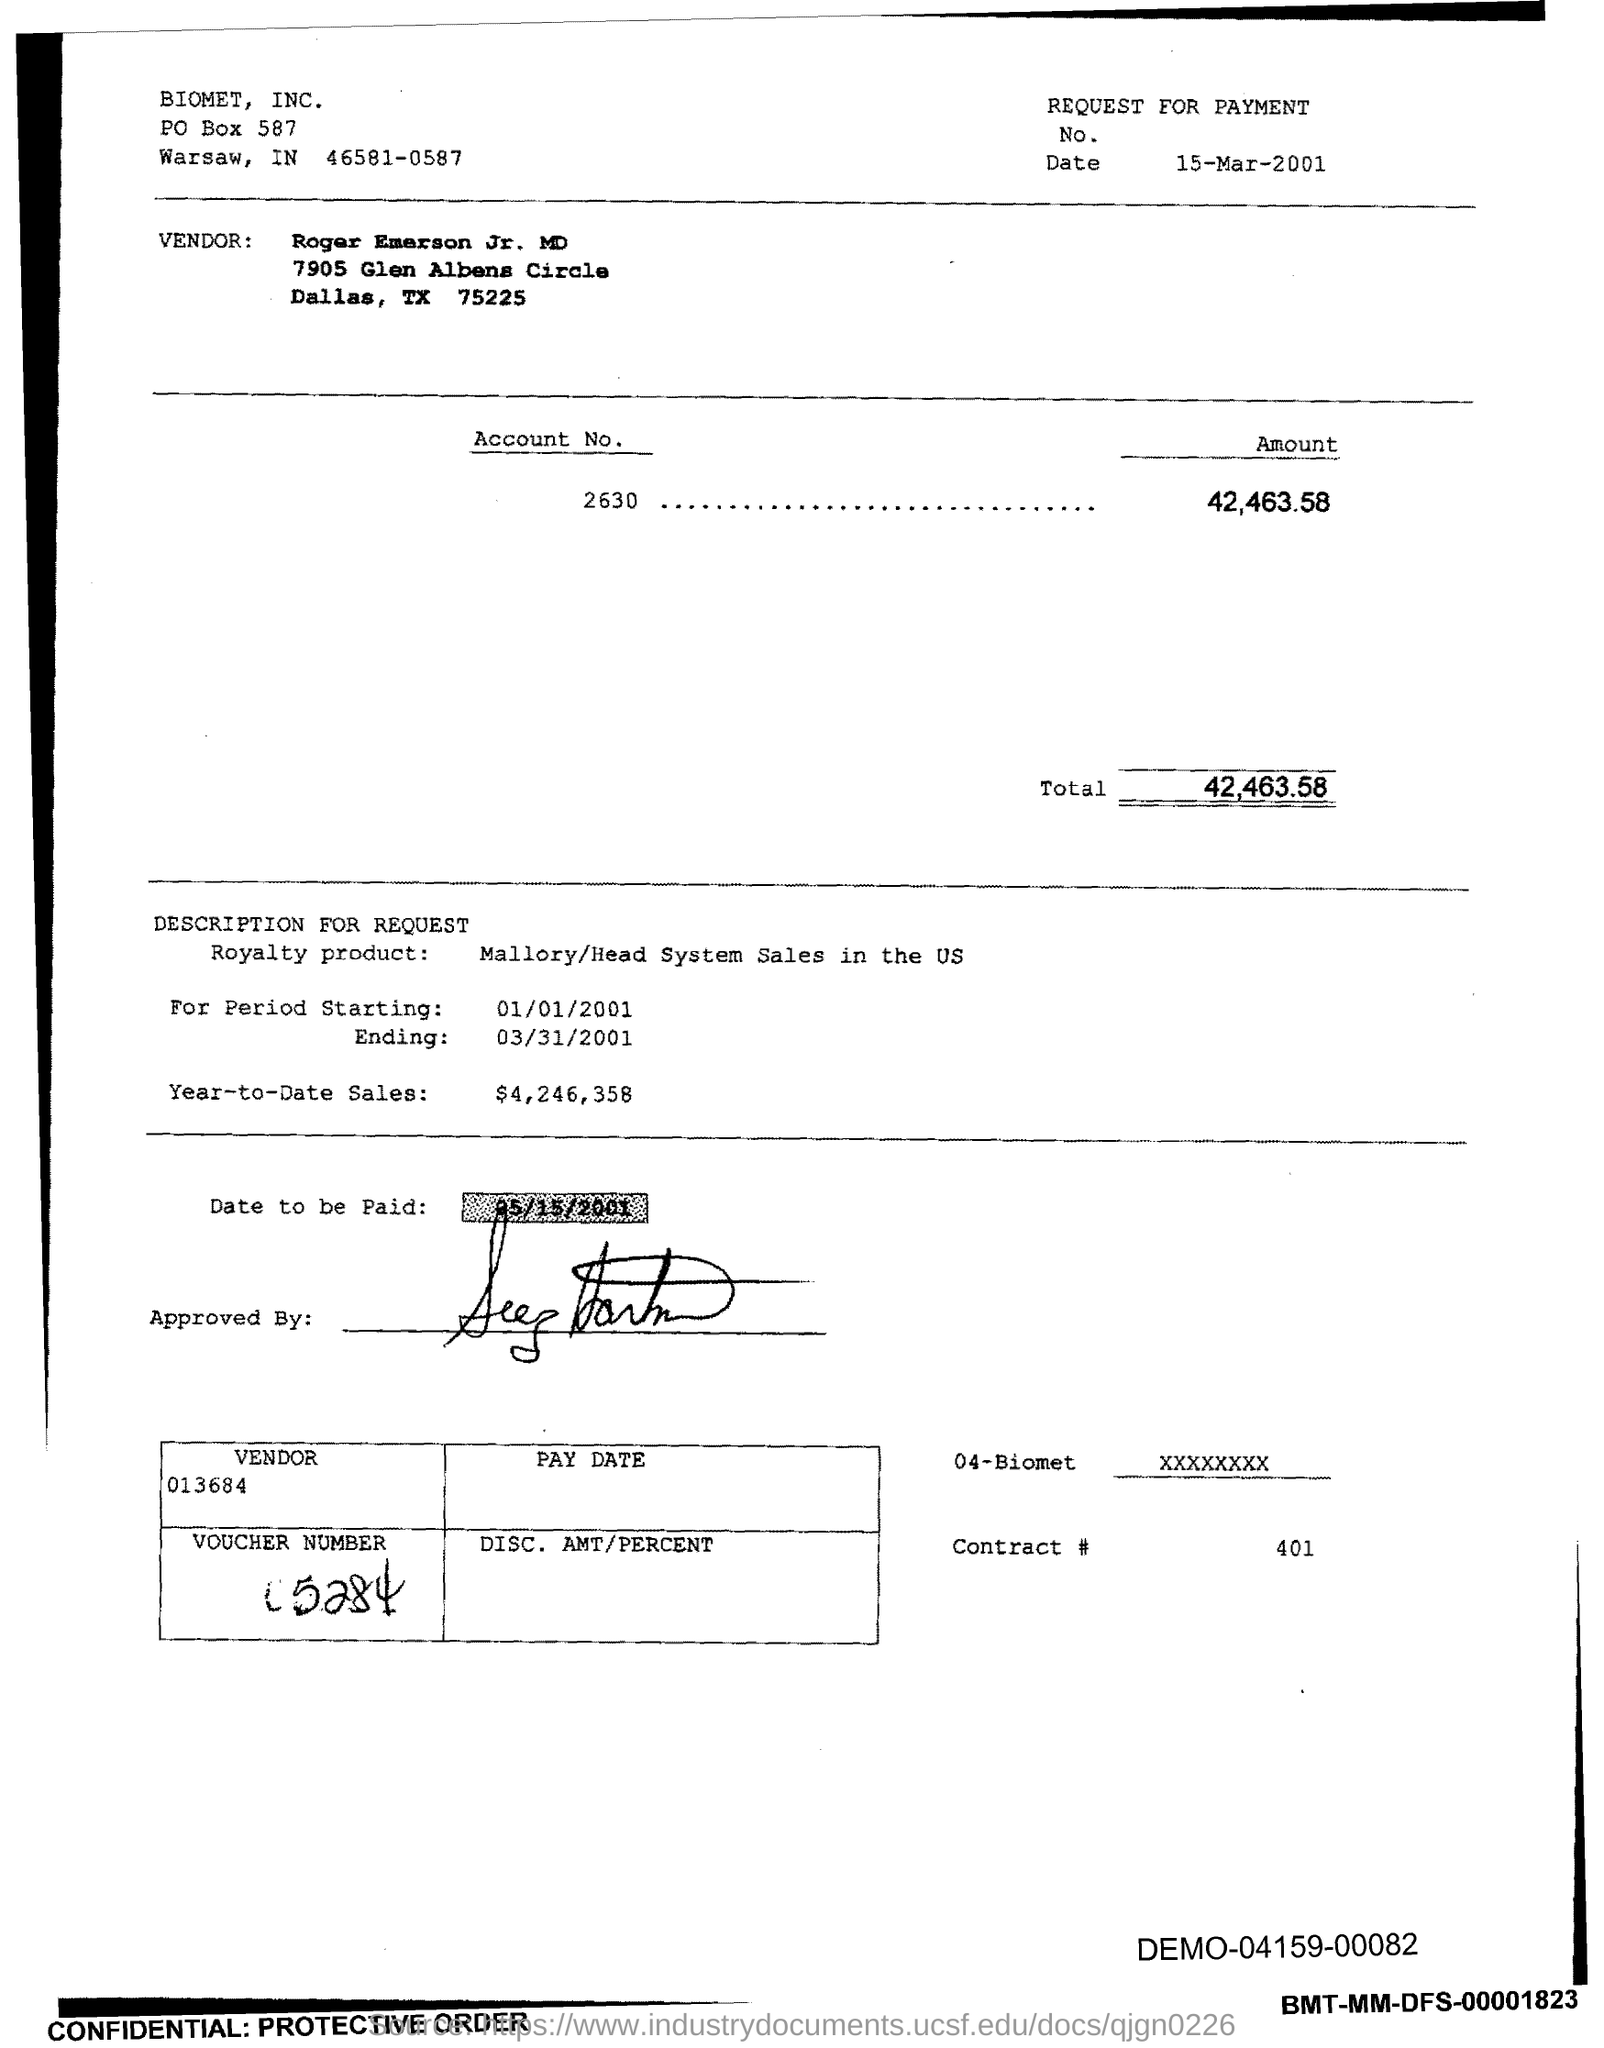What is the Date?
Offer a terse response. 15-Mar-2001. What is the amount for Account No. 2630?
Give a very brief answer. 42,463.58. What is the Total?
Offer a terse response. 42,463.58. What is the Year-to-date sales?
Provide a short and direct response. $4,246,358. What is the Vendor number?
Provide a succinct answer. 013684. What is the Contract #?
Keep it short and to the point. 401. 